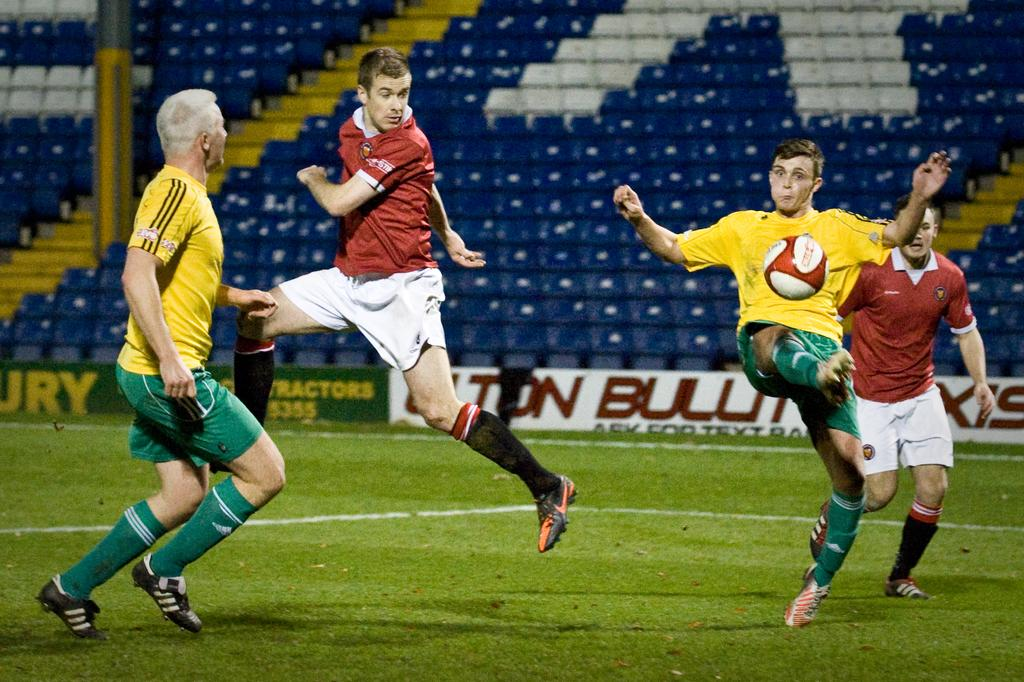<image>
Relay a brief, clear account of the picture shown. soccer players on a field with ads for something ending in URY 